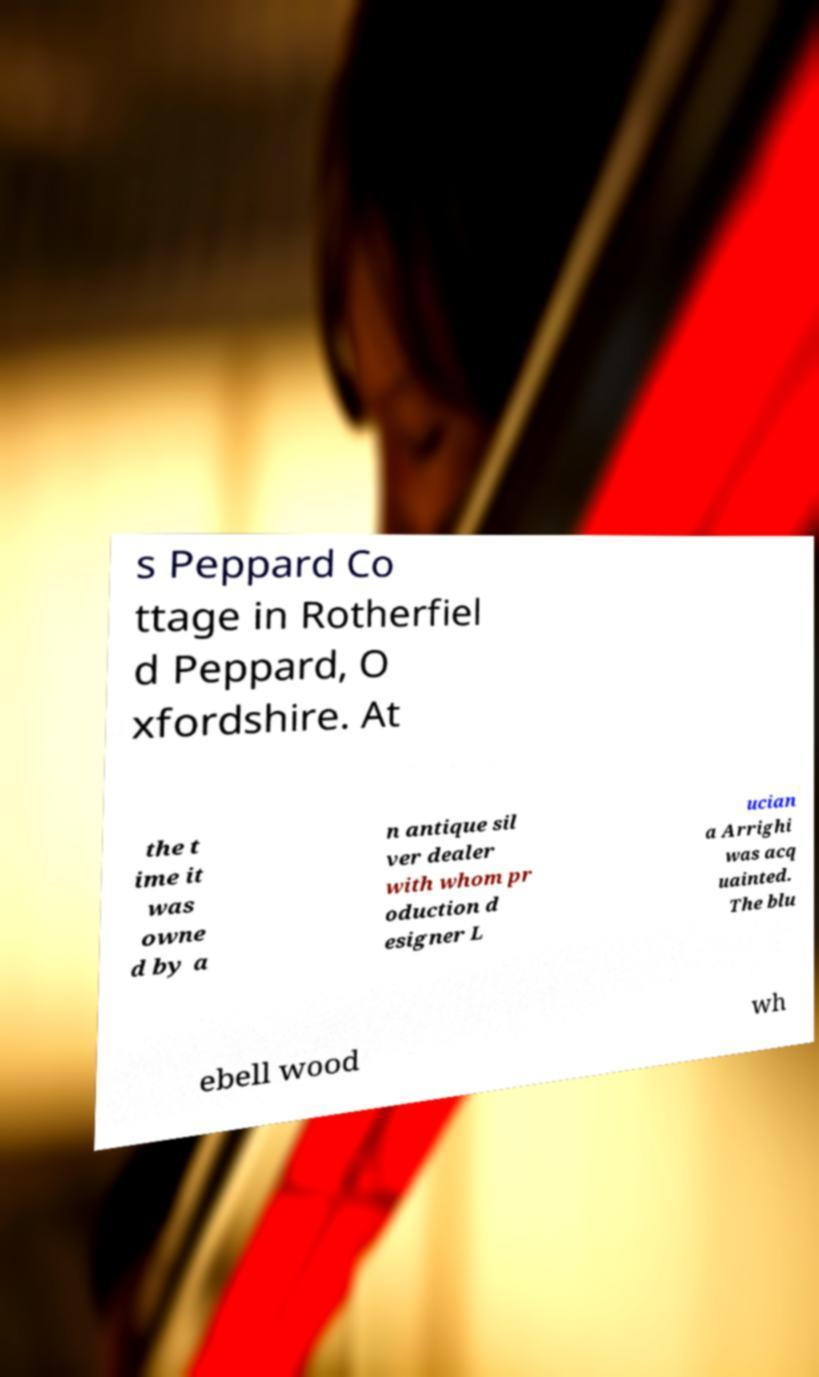There's text embedded in this image that I need extracted. Can you transcribe it verbatim? s Peppard Co ttage in Rotherfiel d Peppard, O xfordshire. At the t ime it was owne d by a n antique sil ver dealer with whom pr oduction d esigner L ucian a Arrighi was acq uainted. The blu ebell wood wh 